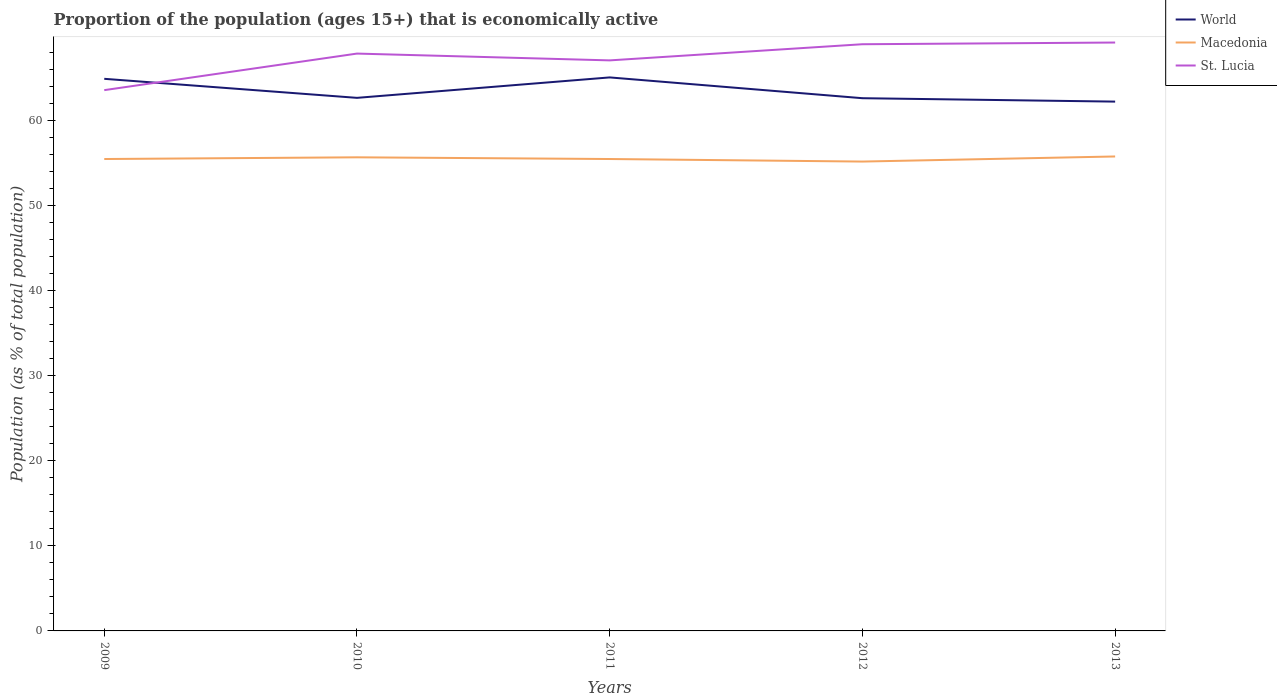Does the line corresponding to Macedonia intersect with the line corresponding to World?
Make the answer very short. No. Across all years, what is the maximum proportion of the population that is economically active in Macedonia?
Offer a terse response. 55.2. In which year was the proportion of the population that is economically active in World maximum?
Give a very brief answer. 2013. What is the total proportion of the population that is economically active in World in the graph?
Your answer should be compact. 0.04. What is the difference between the highest and the second highest proportion of the population that is economically active in Macedonia?
Your response must be concise. 0.6. Is the proportion of the population that is economically active in World strictly greater than the proportion of the population that is economically active in Macedonia over the years?
Offer a terse response. No. What is the difference between two consecutive major ticks on the Y-axis?
Offer a very short reply. 10. Are the values on the major ticks of Y-axis written in scientific E-notation?
Give a very brief answer. No. Does the graph contain grids?
Ensure brevity in your answer.  No. How are the legend labels stacked?
Provide a succinct answer. Vertical. What is the title of the graph?
Ensure brevity in your answer.  Proportion of the population (ages 15+) that is economically active. What is the label or title of the Y-axis?
Provide a succinct answer. Population (as % of total population). What is the Population (as % of total population) in World in 2009?
Your answer should be compact. 64.93. What is the Population (as % of total population) in Macedonia in 2009?
Keep it short and to the point. 55.5. What is the Population (as % of total population) in St. Lucia in 2009?
Provide a short and direct response. 63.6. What is the Population (as % of total population) in World in 2010?
Ensure brevity in your answer.  62.69. What is the Population (as % of total population) in Macedonia in 2010?
Give a very brief answer. 55.7. What is the Population (as % of total population) of St. Lucia in 2010?
Your answer should be compact. 67.9. What is the Population (as % of total population) of World in 2011?
Your answer should be compact. 65.1. What is the Population (as % of total population) in Macedonia in 2011?
Keep it short and to the point. 55.5. What is the Population (as % of total population) in St. Lucia in 2011?
Provide a short and direct response. 67.1. What is the Population (as % of total population) of World in 2012?
Provide a short and direct response. 62.65. What is the Population (as % of total population) in Macedonia in 2012?
Your answer should be compact. 55.2. What is the Population (as % of total population) of St. Lucia in 2012?
Your answer should be very brief. 69. What is the Population (as % of total population) in World in 2013?
Your answer should be very brief. 62.25. What is the Population (as % of total population) in Macedonia in 2013?
Provide a succinct answer. 55.8. What is the Population (as % of total population) in St. Lucia in 2013?
Give a very brief answer. 69.2. Across all years, what is the maximum Population (as % of total population) of World?
Provide a succinct answer. 65.1. Across all years, what is the maximum Population (as % of total population) in Macedonia?
Ensure brevity in your answer.  55.8. Across all years, what is the maximum Population (as % of total population) of St. Lucia?
Your response must be concise. 69.2. Across all years, what is the minimum Population (as % of total population) of World?
Your response must be concise. 62.25. Across all years, what is the minimum Population (as % of total population) in Macedonia?
Keep it short and to the point. 55.2. Across all years, what is the minimum Population (as % of total population) in St. Lucia?
Give a very brief answer. 63.6. What is the total Population (as % of total population) of World in the graph?
Make the answer very short. 317.63. What is the total Population (as % of total population) in Macedonia in the graph?
Make the answer very short. 277.7. What is the total Population (as % of total population) of St. Lucia in the graph?
Ensure brevity in your answer.  336.8. What is the difference between the Population (as % of total population) of World in 2009 and that in 2010?
Offer a very short reply. 2.24. What is the difference between the Population (as % of total population) of World in 2009 and that in 2011?
Your response must be concise. -0.16. What is the difference between the Population (as % of total population) in World in 2009 and that in 2012?
Your answer should be compact. 2.28. What is the difference between the Population (as % of total population) of World in 2009 and that in 2013?
Offer a terse response. 2.68. What is the difference between the Population (as % of total population) of Macedonia in 2009 and that in 2013?
Your answer should be compact. -0.3. What is the difference between the Population (as % of total population) in St. Lucia in 2009 and that in 2013?
Provide a short and direct response. -5.6. What is the difference between the Population (as % of total population) in World in 2010 and that in 2011?
Give a very brief answer. -2.4. What is the difference between the Population (as % of total population) in Macedonia in 2010 and that in 2011?
Offer a terse response. 0.2. What is the difference between the Population (as % of total population) in St. Lucia in 2010 and that in 2011?
Provide a short and direct response. 0.8. What is the difference between the Population (as % of total population) of World in 2010 and that in 2012?
Provide a succinct answer. 0.04. What is the difference between the Population (as % of total population) of Macedonia in 2010 and that in 2012?
Make the answer very short. 0.5. What is the difference between the Population (as % of total population) in St. Lucia in 2010 and that in 2012?
Your answer should be very brief. -1.1. What is the difference between the Population (as % of total population) of World in 2010 and that in 2013?
Provide a succinct answer. 0.44. What is the difference between the Population (as % of total population) in World in 2011 and that in 2012?
Your response must be concise. 2.44. What is the difference between the Population (as % of total population) in Macedonia in 2011 and that in 2012?
Your answer should be compact. 0.3. What is the difference between the Population (as % of total population) in St. Lucia in 2011 and that in 2012?
Offer a terse response. -1.9. What is the difference between the Population (as % of total population) in World in 2011 and that in 2013?
Offer a very short reply. 2.85. What is the difference between the Population (as % of total population) in Macedonia in 2011 and that in 2013?
Your answer should be very brief. -0.3. What is the difference between the Population (as % of total population) in World in 2012 and that in 2013?
Offer a very short reply. 0.4. What is the difference between the Population (as % of total population) of Macedonia in 2012 and that in 2013?
Offer a terse response. -0.6. What is the difference between the Population (as % of total population) in World in 2009 and the Population (as % of total population) in Macedonia in 2010?
Provide a succinct answer. 9.23. What is the difference between the Population (as % of total population) in World in 2009 and the Population (as % of total population) in St. Lucia in 2010?
Your response must be concise. -2.97. What is the difference between the Population (as % of total population) of Macedonia in 2009 and the Population (as % of total population) of St. Lucia in 2010?
Ensure brevity in your answer.  -12.4. What is the difference between the Population (as % of total population) in World in 2009 and the Population (as % of total population) in Macedonia in 2011?
Your answer should be very brief. 9.43. What is the difference between the Population (as % of total population) in World in 2009 and the Population (as % of total population) in St. Lucia in 2011?
Make the answer very short. -2.17. What is the difference between the Population (as % of total population) of World in 2009 and the Population (as % of total population) of Macedonia in 2012?
Give a very brief answer. 9.73. What is the difference between the Population (as % of total population) of World in 2009 and the Population (as % of total population) of St. Lucia in 2012?
Make the answer very short. -4.07. What is the difference between the Population (as % of total population) in Macedonia in 2009 and the Population (as % of total population) in St. Lucia in 2012?
Your answer should be compact. -13.5. What is the difference between the Population (as % of total population) in World in 2009 and the Population (as % of total population) in Macedonia in 2013?
Offer a terse response. 9.13. What is the difference between the Population (as % of total population) of World in 2009 and the Population (as % of total population) of St. Lucia in 2013?
Make the answer very short. -4.27. What is the difference between the Population (as % of total population) of Macedonia in 2009 and the Population (as % of total population) of St. Lucia in 2013?
Offer a very short reply. -13.7. What is the difference between the Population (as % of total population) of World in 2010 and the Population (as % of total population) of Macedonia in 2011?
Your answer should be very brief. 7.19. What is the difference between the Population (as % of total population) of World in 2010 and the Population (as % of total population) of St. Lucia in 2011?
Your answer should be very brief. -4.41. What is the difference between the Population (as % of total population) of Macedonia in 2010 and the Population (as % of total population) of St. Lucia in 2011?
Make the answer very short. -11.4. What is the difference between the Population (as % of total population) of World in 2010 and the Population (as % of total population) of Macedonia in 2012?
Provide a short and direct response. 7.49. What is the difference between the Population (as % of total population) in World in 2010 and the Population (as % of total population) in St. Lucia in 2012?
Make the answer very short. -6.31. What is the difference between the Population (as % of total population) of World in 2010 and the Population (as % of total population) of Macedonia in 2013?
Offer a very short reply. 6.89. What is the difference between the Population (as % of total population) in World in 2010 and the Population (as % of total population) in St. Lucia in 2013?
Keep it short and to the point. -6.51. What is the difference between the Population (as % of total population) in World in 2011 and the Population (as % of total population) in Macedonia in 2012?
Keep it short and to the point. 9.9. What is the difference between the Population (as % of total population) of World in 2011 and the Population (as % of total population) of St. Lucia in 2012?
Your answer should be compact. -3.9. What is the difference between the Population (as % of total population) in Macedonia in 2011 and the Population (as % of total population) in St. Lucia in 2012?
Keep it short and to the point. -13.5. What is the difference between the Population (as % of total population) of World in 2011 and the Population (as % of total population) of Macedonia in 2013?
Your answer should be compact. 9.3. What is the difference between the Population (as % of total population) in World in 2011 and the Population (as % of total population) in St. Lucia in 2013?
Your answer should be very brief. -4.1. What is the difference between the Population (as % of total population) in Macedonia in 2011 and the Population (as % of total population) in St. Lucia in 2013?
Your response must be concise. -13.7. What is the difference between the Population (as % of total population) of World in 2012 and the Population (as % of total population) of Macedonia in 2013?
Your answer should be compact. 6.85. What is the difference between the Population (as % of total population) of World in 2012 and the Population (as % of total population) of St. Lucia in 2013?
Your answer should be compact. -6.55. What is the difference between the Population (as % of total population) in Macedonia in 2012 and the Population (as % of total population) in St. Lucia in 2013?
Give a very brief answer. -14. What is the average Population (as % of total population) of World per year?
Your answer should be very brief. 63.53. What is the average Population (as % of total population) in Macedonia per year?
Provide a succinct answer. 55.54. What is the average Population (as % of total population) in St. Lucia per year?
Your answer should be compact. 67.36. In the year 2009, what is the difference between the Population (as % of total population) in World and Population (as % of total population) in Macedonia?
Make the answer very short. 9.43. In the year 2009, what is the difference between the Population (as % of total population) in World and Population (as % of total population) in St. Lucia?
Provide a succinct answer. 1.33. In the year 2010, what is the difference between the Population (as % of total population) in World and Population (as % of total population) in Macedonia?
Offer a terse response. 6.99. In the year 2010, what is the difference between the Population (as % of total population) of World and Population (as % of total population) of St. Lucia?
Make the answer very short. -5.21. In the year 2010, what is the difference between the Population (as % of total population) in Macedonia and Population (as % of total population) in St. Lucia?
Offer a very short reply. -12.2. In the year 2011, what is the difference between the Population (as % of total population) of World and Population (as % of total population) of Macedonia?
Offer a very short reply. 9.6. In the year 2011, what is the difference between the Population (as % of total population) in World and Population (as % of total population) in St. Lucia?
Offer a very short reply. -2. In the year 2012, what is the difference between the Population (as % of total population) of World and Population (as % of total population) of Macedonia?
Offer a very short reply. 7.45. In the year 2012, what is the difference between the Population (as % of total population) of World and Population (as % of total population) of St. Lucia?
Provide a short and direct response. -6.35. In the year 2012, what is the difference between the Population (as % of total population) in Macedonia and Population (as % of total population) in St. Lucia?
Keep it short and to the point. -13.8. In the year 2013, what is the difference between the Population (as % of total population) of World and Population (as % of total population) of Macedonia?
Keep it short and to the point. 6.45. In the year 2013, what is the difference between the Population (as % of total population) in World and Population (as % of total population) in St. Lucia?
Provide a short and direct response. -6.95. What is the ratio of the Population (as % of total population) in World in 2009 to that in 2010?
Offer a terse response. 1.04. What is the ratio of the Population (as % of total population) in St. Lucia in 2009 to that in 2010?
Your response must be concise. 0.94. What is the ratio of the Population (as % of total population) in World in 2009 to that in 2011?
Your response must be concise. 1. What is the ratio of the Population (as % of total population) in Macedonia in 2009 to that in 2011?
Keep it short and to the point. 1. What is the ratio of the Population (as % of total population) of St. Lucia in 2009 to that in 2011?
Make the answer very short. 0.95. What is the ratio of the Population (as % of total population) of World in 2009 to that in 2012?
Offer a very short reply. 1.04. What is the ratio of the Population (as % of total population) in Macedonia in 2009 to that in 2012?
Provide a succinct answer. 1.01. What is the ratio of the Population (as % of total population) of St. Lucia in 2009 to that in 2012?
Ensure brevity in your answer.  0.92. What is the ratio of the Population (as % of total population) in World in 2009 to that in 2013?
Offer a terse response. 1.04. What is the ratio of the Population (as % of total population) of Macedonia in 2009 to that in 2013?
Ensure brevity in your answer.  0.99. What is the ratio of the Population (as % of total population) of St. Lucia in 2009 to that in 2013?
Make the answer very short. 0.92. What is the ratio of the Population (as % of total population) in World in 2010 to that in 2011?
Provide a succinct answer. 0.96. What is the ratio of the Population (as % of total population) of Macedonia in 2010 to that in 2011?
Ensure brevity in your answer.  1. What is the ratio of the Population (as % of total population) of St. Lucia in 2010 to that in 2011?
Offer a very short reply. 1.01. What is the ratio of the Population (as % of total population) of World in 2010 to that in 2012?
Give a very brief answer. 1. What is the ratio of the Population (as % of total population) of Macedonia in 2010 to that in 2012?
Ensure brevity in your answer.  1.01. What is the ratio of the Population (as % of total population) of St. Lucia in 2010 to that in 2012?
Keep it short and to the point. 0.98. What is the ratio of the Population (as % of total population) in World in 2010 to that in 2013?
Your response must be concise. 1.01. What is the ratio of the Population (as % of total population) of St. Lucia in 2010 to that in 2013?
Offer a very short reply. 0.98. What is the ratio of the Population (as % of total population) in World in 2011 to that in 2012?
Offer a very short reply. 1.04. What is the ratio of the Population (as % of total population) in Macedonia in 2011 to that in 2012?
Offer a very short reply. 1.01. What is the ratio of the Population (as % of total population) of St. Lucia in 2011 to that in 2012?
Ensure brevity in your answer.  0.97. What is the ratio of the Population (as % of total population) in World in 2011 to that in 2013?
Your answer should be very brief. 1.05. What is the ratio of the Population (as % of total population) in St. Lucia in 2011 to that in 2013?
Your response must be concise. 0.97. What is the ratio of the Population (as % of total population) of World in 2012 to that in 2013?
Keep it short and to the point. 1.01. What is the ratio of the Population (as % of total population) of Macedonia in 2012 to that in 2013?
Your answer should be very brief. 0.99. What is the difference between the highest and the second highest Population (as % of total population) in World?
Keep it short and to the point. 0.16. What is the difference between the highest and the second highest Population (as % of total population) in St. Lucia?
Give a very brief answer. 0.2. What is the difference between the highest and the lowest Population (as % of total population) in World?
Ensure brevity in your answer.  2.85. What is the difference between the highest and the lowest Population (as % of total population) in Macedonia?
Provide a short and direct response. 0.6. What is the difference between the highest and the lowest Population (as % of total population) of St. Lucia?
Provide a short and direct response. 5.6. 